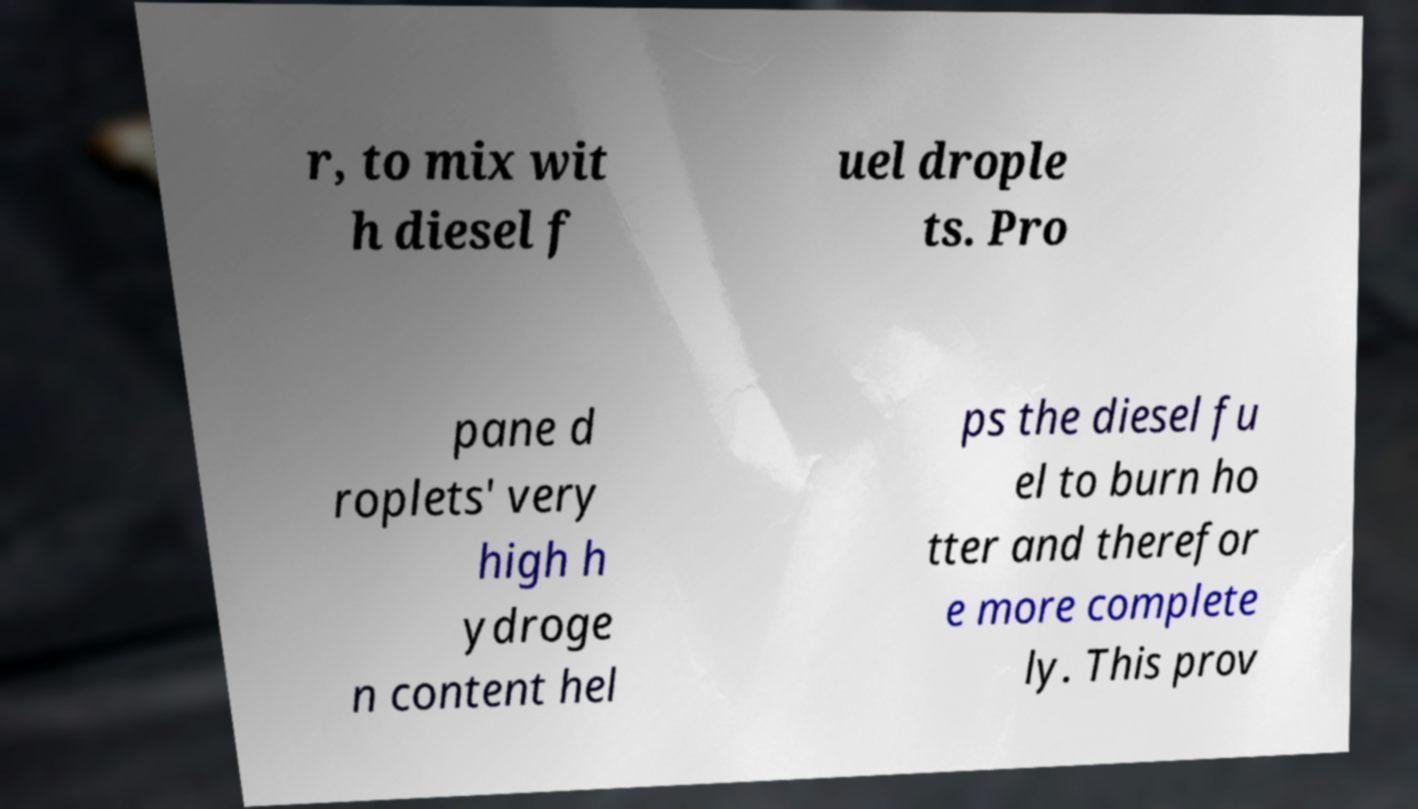Can you accurately transcribe the text from the provided image for me? r, to mix wit h diesel f uel drople ts. Pro pane d roplets' very high h ydroge n content hel ps the diesel fu el to burn ho tter and therefor e more complete ly. This prov 